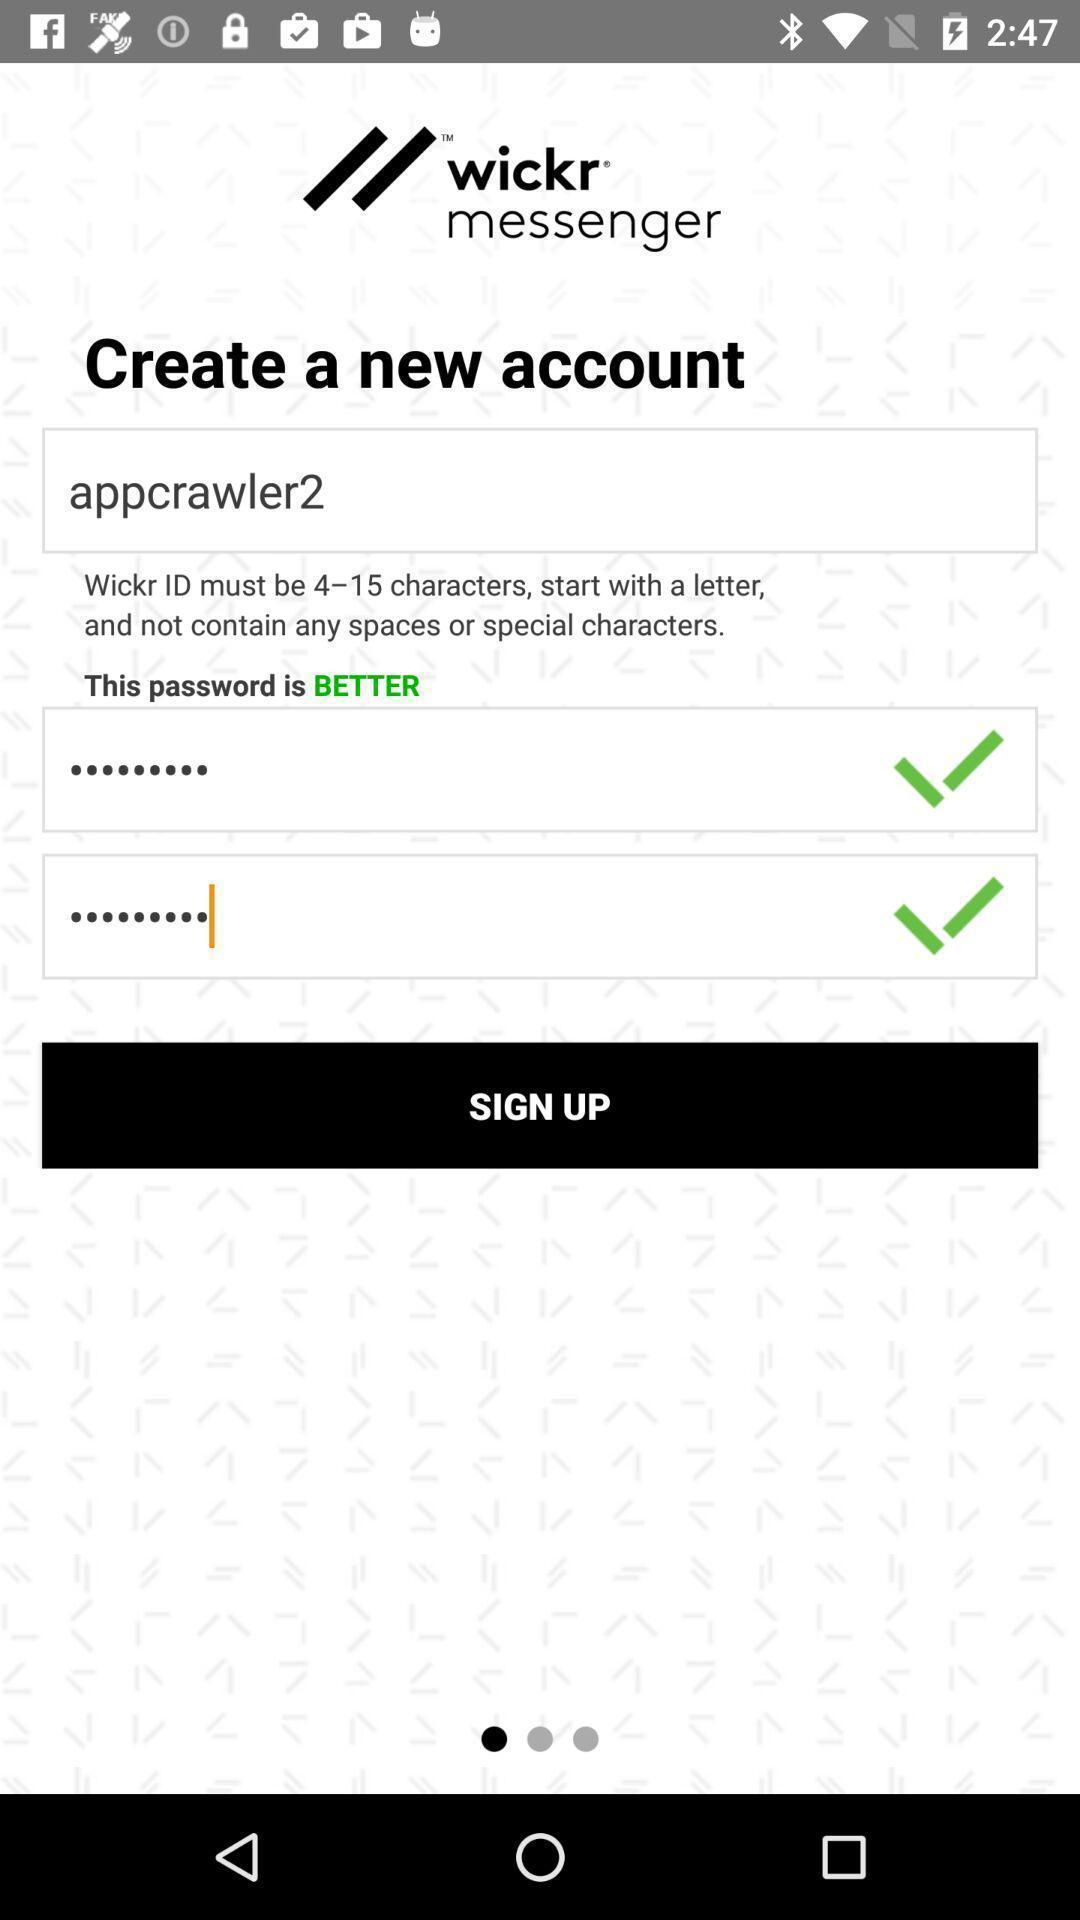What can you discern from this picture? Start page of a social app. 